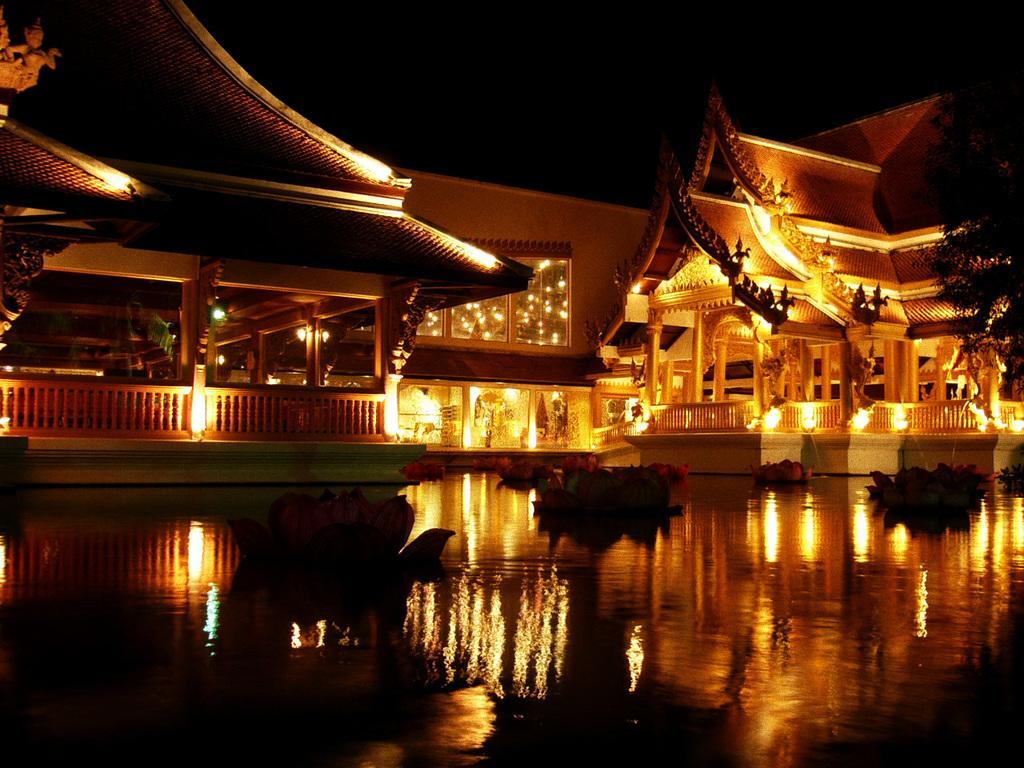In one or two sentences, can you explain what this image depicts? In this image I can see flowers on the water. There are buildings, sculptures, lights and there is a dark background. 